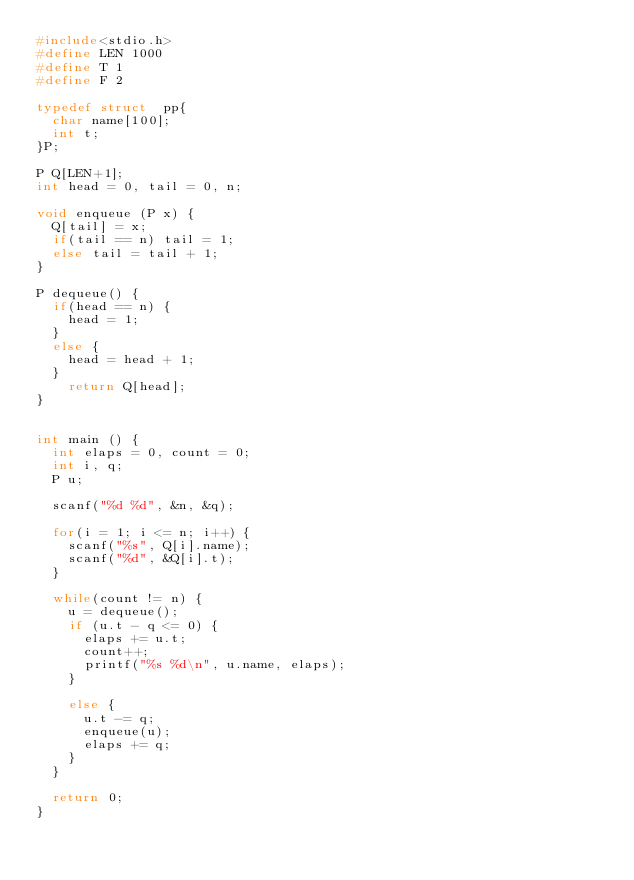Convert code to text. <code><loc_0><loc_0><loc_500><loc_500><_C_>#include<stdio.h>
#define LEN 1000
#define T 1
#define F 2

typedef struct  pp{
  char name[100];
  int t;
}P;

P Q[LEN+1];
int head = 0, tail = 0, n;

void enqueue (P x) {
  Q[tail] = x;
  if(tail == n) tail = 1;
  else tail = tail + 1;
}

P dequeue() {
  if(head == n) {
    head = 1;
  }
  else {
    head = head + 1;
  }
    return Q[head];
}


int main () {
  int elaps = 0, count = 0;
  int i, q;
  P u;

  scanf("%d %d", &n, &q);

  for(i = 1; i <= n; i++) {
    scanf("%s", Q[i].name);
    scanf("%d", &Q[i].t);
  }

  while(count != n) {
    u = dequeue();
    if (u.t - q <= 0) {
      elaps += u.t;
      count++;
      printf("%s %d\n", u.name, elaps);
    }

    else {
      u.t -= q;
      enqueue(u);
      elaps += q;
    }
  }

  return 0;
}</code> 